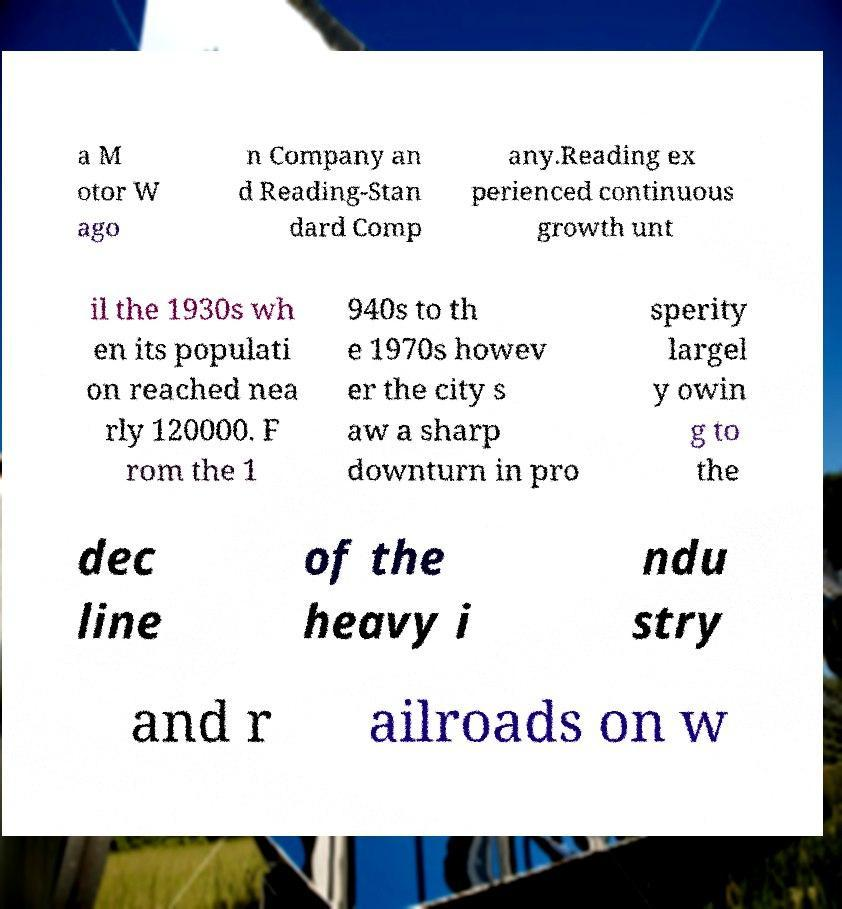Could you assist in decoding the text presented in this image and type it out clearly? a M otor W ago n Company an d Reading-Stan dard Comp any.Reading ex perienced continuous growth unt il the 1930s wh en its populati on reached nea rly 120000. F rom the 1 940s to th e 1970s howev er the city s aw a sharp downturn in pro sperity largel y owin g to the dec line of the heavy i ndu stry and r ailroads on w 